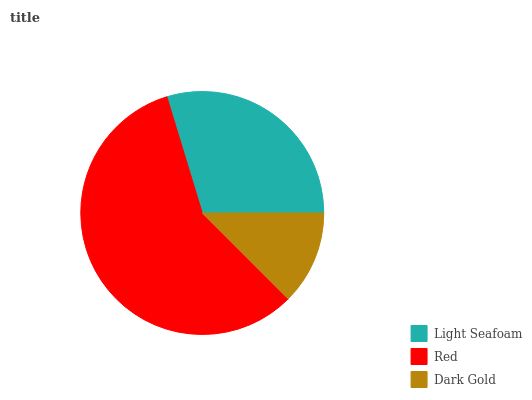Is Dark Gold the minimum?
Answer yes or no. Yes. Is Red the maximum?
Answer yes or no. Yes. Is Red the minimum?
Answer yes or no. No. Is Dark Gold the maximum?
Answer yes or no. No. Is Red greater than Dark Gold?
Answer yes or no. Yes. Is Dark Gold less than Red?
Answer yes or no. Yes. Is Dark Gold greater than Red?
Answer yes or no. No. Is Red less than Dark Gold?
Answer yes or no. No. Is Light Seafoam the high median?
Answer yes or no. Yes. Is Light Seafoam the low median?
Answer yes or no. Yes. Is Dark Gold the high median?
Answer yes or no. No. Is Dark Gold the low median?
Answer yes or no. No. 